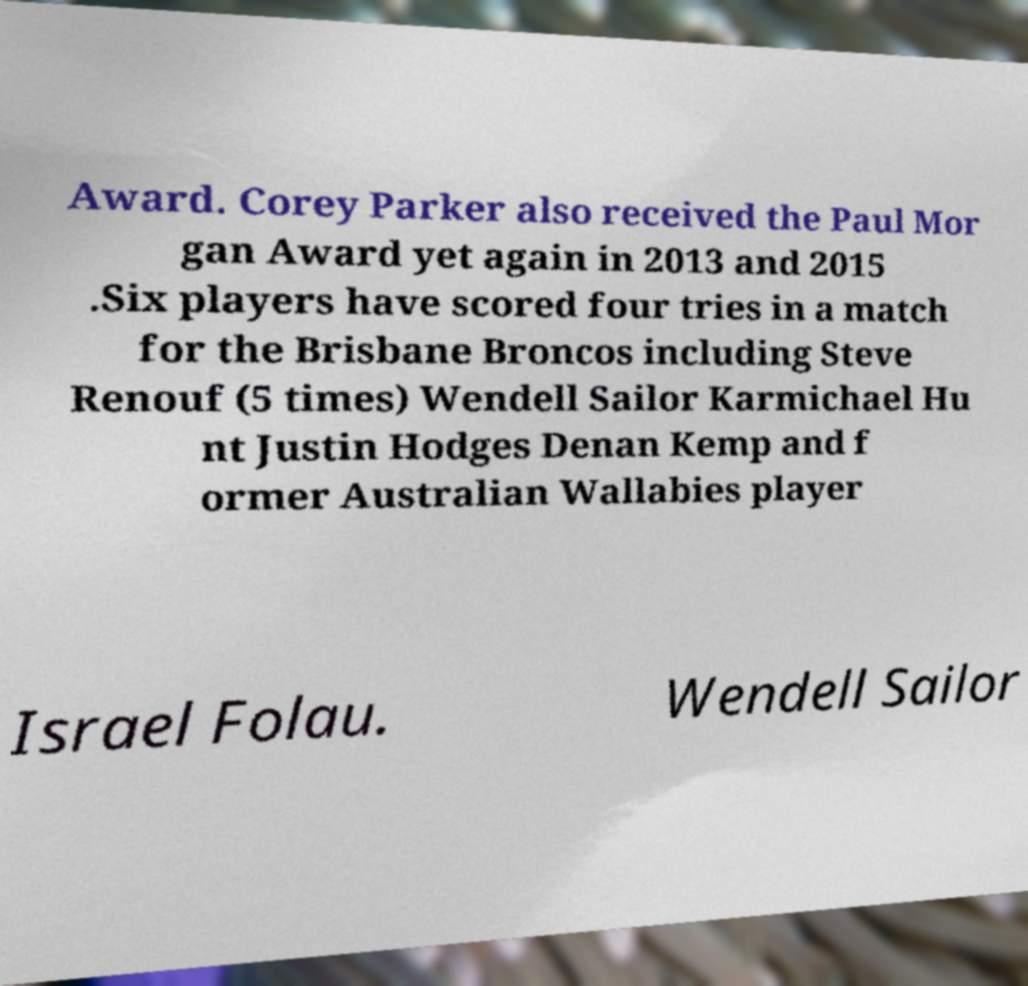Can you read and provide the text displayed in the image?This photo seems to have some interesting text. Can you extract and type it out for me? Award. Corey Parker also received the Paul Mor gan Award yet again in 2013 and 2015 .Six players have scored four tries in a match for the Brisbane Broncos including Steve Renouf (5 times) Wendell Sailor Karmichael Hu nt Justin Hodges Denan Kemp and f ormer Australian Wallabies player Israel Folau. Wendell Sailor 